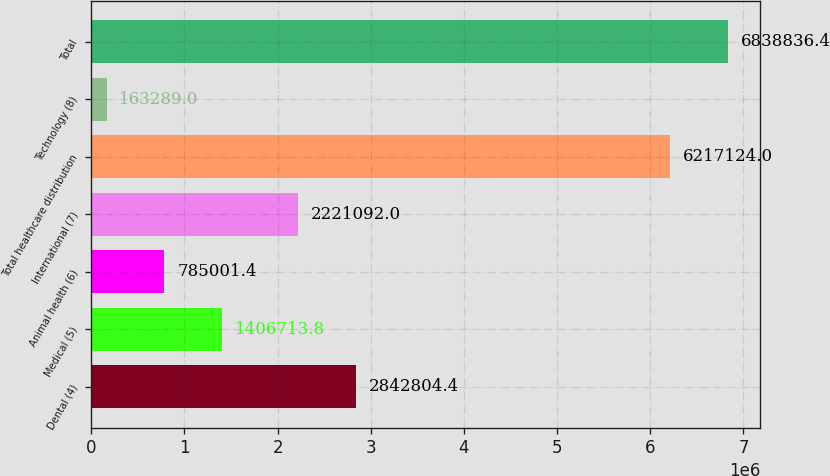<chart> <loc_0><loc_0><loc_500><loc_500><bar_chart><fcel>Dental (4)<fcel>Medical (5)<fcel>Animal health (6)<fcel>International (7)<fcel>Total healthcare distribution<fcel>Technology (8)<fcel>Total<nl><fcel>2.8428e+06<fcel>1.40671e+06<fcel>785001<fcel>2.22109e+06<fcel>6.21712e+06<fcel>163289<fcel>6.83884e+06<nl></chart> 